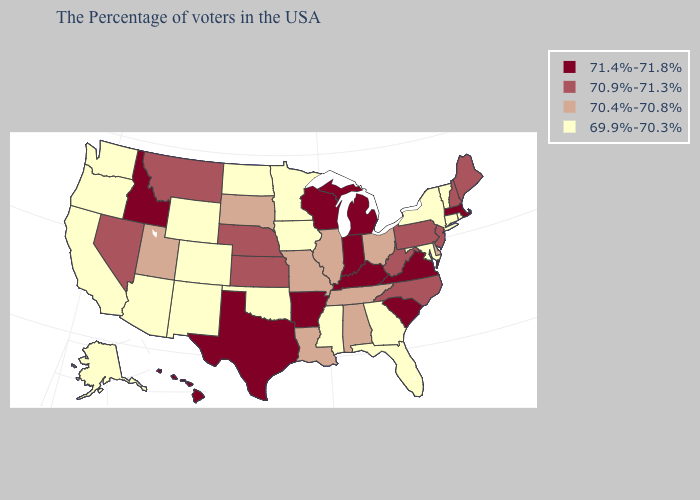What is the value of Maryland?
Concise answer only. 69.9%-70.3%. Does Alaska have the lowest value in the USA?
Answer briefly. Yes. Does the map have missing data?
Short answer required. No. Among the states that border North Dakota , which have the lowest value?
Give a very brief answer. Minnesota. What is the value of New Mexico?
Keep it brief. 69.9%-70.3%. Does South Carolina have the highest value in the USA?
Be succinct. Yes. Among the states that border Minnesota , does South Dakota have the lowest value?
Short answer required. No. What is the highest value in the USA?
Short answer required. 71.4%-71.8%. Name the states that have a value in the range 70.9%-71.3%?
Be succinct. Maine, New Hampshire, New Jersey, Pennsylvania, North Carolina, West Virginia, Kansas, Nebraska, Montana, Nevada. Name the states that have a value in the range 70.9%-71.3%?
Give a very brief answer. Maine, New Hampshire, New Jersey, Pennsylvania, North Carolina, West Virginia, Kansas, Nebraska, Montana, Nevada. Among the states that border Mississippi , which have the highest value?
Concise answer only. Arkansas. How many symbols are there in the legend?
Give a very brief answer. 4. Does Florida have a lower value than Georgia?
Keep it brief. No. Does the map have missing data?
Keep it brief. No. What is the value of North Carolina?
Short answer required. 70.9%-71.3%. 